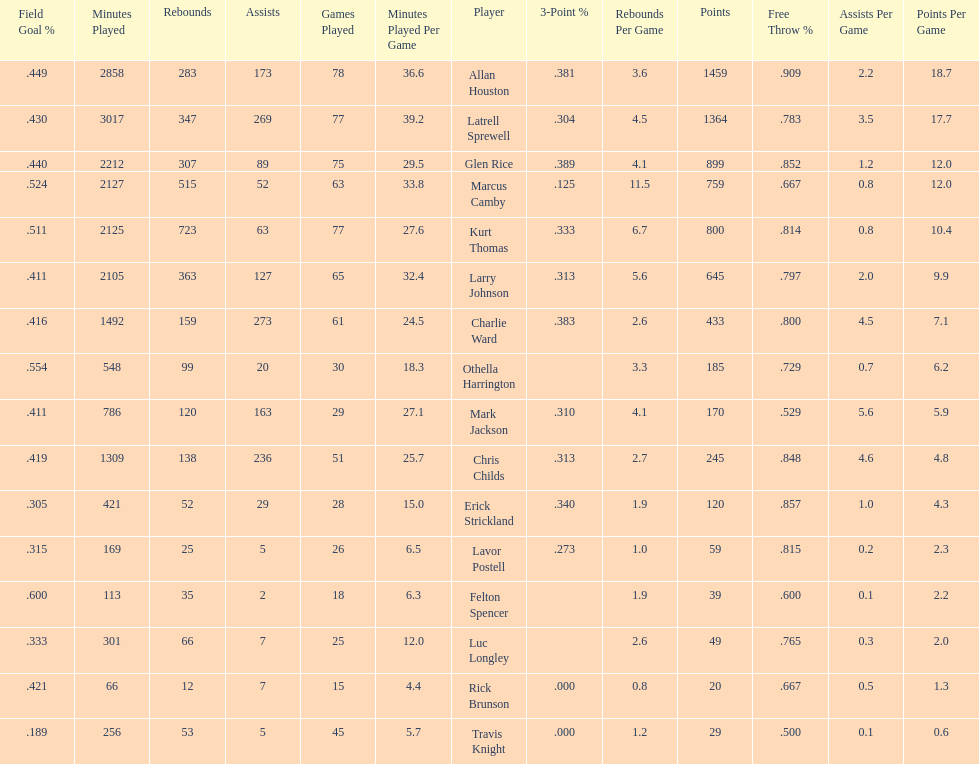Who scored more points, larry johnson or charlie ward? Larry Johnson. 